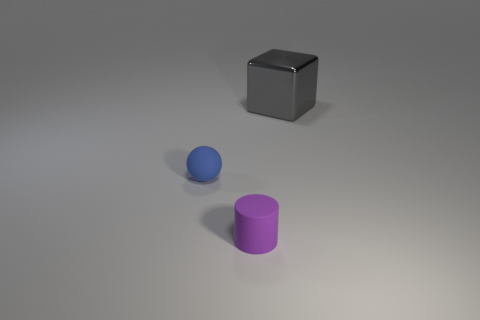Are there any other things that are made of the same material as the block?
Give a very brief answer. No. The small blue object that is the same material as the small cylinder is what shape?
Your answer should be compact. Sphere. Is the shape of the matte object that is to the left of the small purple rubber object the same as  the tiny purple object?
Provide a succinct answer. No. How many yellow objects are large objects or tiny cylinders?
Offer a very short reply. 0. Are there an equal number of tiny purple cylinders that are behind the tiny purple rubber cylinder and big metallic cubes that are in front of the small ball?
Offer a terse response. Yes. What is the color of the tiny matte thing behind the small matte object that is right of the small matte thing to the left of the tiny purple cylinder?
Provide a succinct answer. Blue. Is there any other thing that has the same color as the tiny matte sphere?
Your answer should be compact. No. There is a rubber thing behind the cylinder; what size is it?
Keep it short and to the point. Small. What shape is the blue rubber object that is the same size as the purple cylinder?
Your response must be concise. Sphere. Does the tiny thing that is in front of the tiny rubber sphere have the same material as the tiny object that is on the left side of the purple rubber cylinder?
Provide a succinct answer. Yes. 